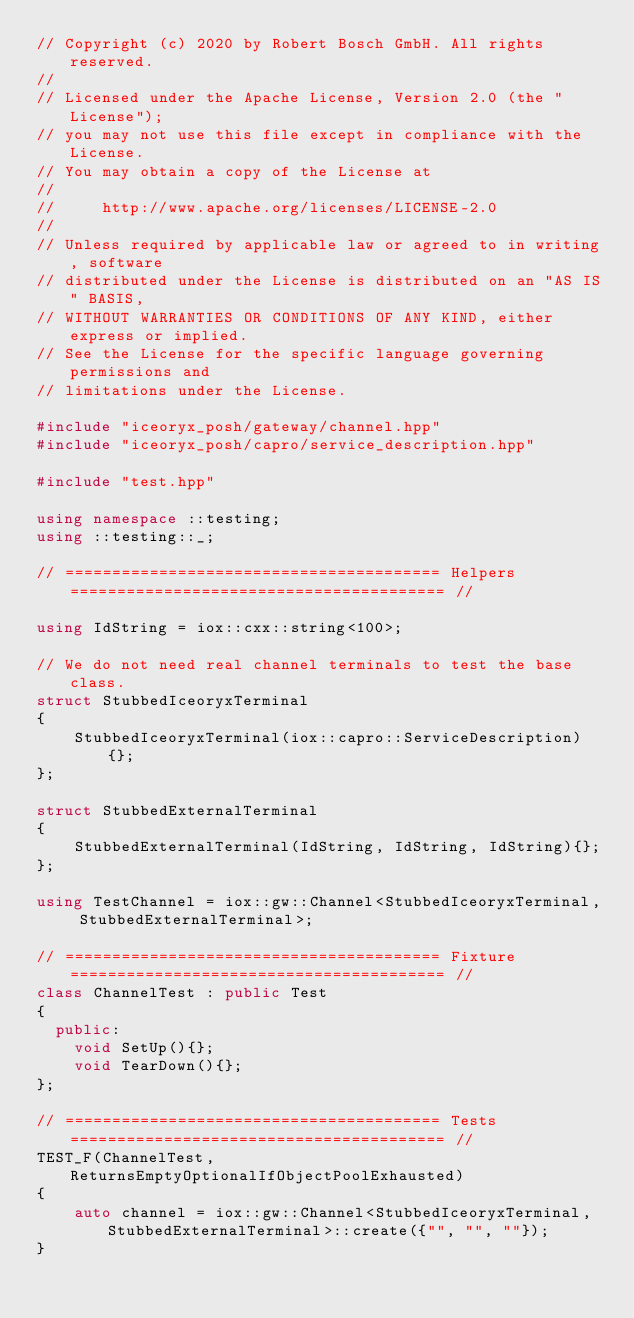Convert code to text. <code><loc_0><loc_0><loc_500><loc_500><_C++_>// Copyright (c) 2020 by Robert Bosch GmbH. All rights reserved.
//
// Licensed under the Apache License, Version 2.0 (the "License");
// you may not use this file except in compliance with the License.
// You may obtain a copy of the License at
//
//     http://www.apache.org/licenses/LICENSE-2.0
//
// Unless required by applicable law or agreed to in writing, software
// distributed under the License is distributed on an "AS IS" BASIS,
// WITHOUT WARRANTIES OR CONDITIONS OF ANY KIND, either express or implied.
// See the License for the specific language governing permissions and
// limitations under the License.

#include "iceoryx_posh/gateway/channel.hpp"
#include "iceoryx_posh/capro/service_description.hpp"

#include "test.hpp"

using namespace ::testing;
using ::testing::_;

// ======================================== Helpers ======================================== //

using IdString = iox::cxx::string<100>;

// We do not need real channel terminals to test the base class.
struct StubbedIceoryxTerminal
{
    StubbedIceoryxTerminal(iox::capro::ServiceDescription){};
};

struct StubbedExternalTerminal
{
    StubbedExternalTerminal(IdString, IdString, IdString){};
};

using TestChannel = iox::gw::Channel<StubbedIceoryxTerminal, StubbedExternalTerminal>;

// ======================================== Fixture ======================================== //
class ChannelTest : public Test
{
  public:
    void SetUp(){};
    void TearDown(){};
};

// ======================================== Tests ======================================== //
TEST_F(ChannelTest, ReturnsEmptyOptionalIfObjectPoolExhausted)
{
    auto channel = iox::gw::Channel<StubbedIceoryxTerminal, StubbedExternalTerminal>::create({"", "", ""});
}
</code> 